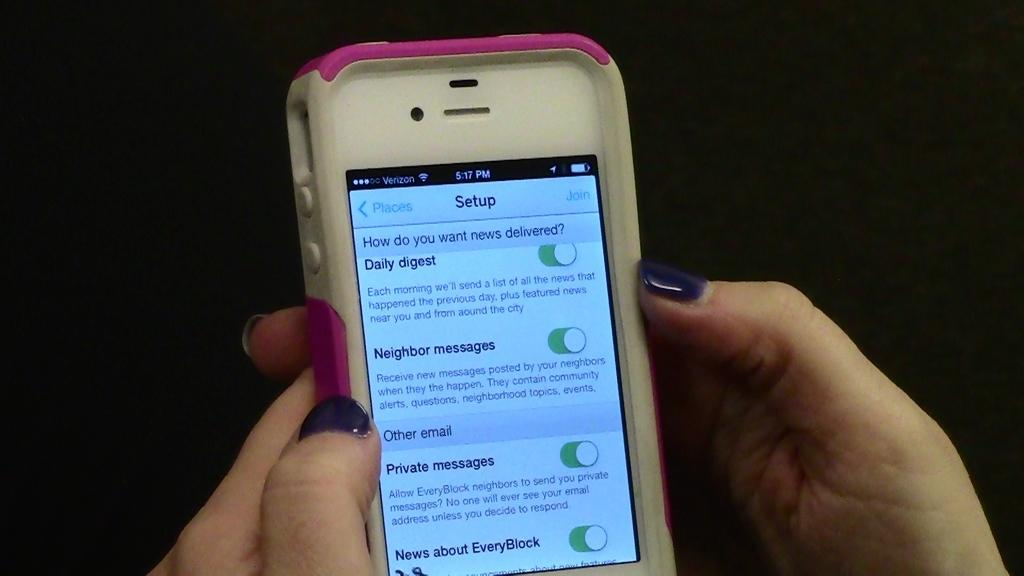<image>
Relay a brief, clear account of the picture shown. Someone holding a white and pink cell phone with a Setup Screen asking how do you want your news delivered 